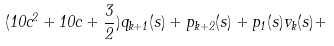Convert formula to latex. <formula><loc_0><loc_0><loc_500><loc_500>( 1 0 c ^ { 2 } + 1 0 c + \frac { 3 } { 2 } ) q _ { k + 1 } ( s ) + p _ { k + 2 } ( s ) + p _ { 1 } ( s ) v _ { k } ( s ) +</formula> 